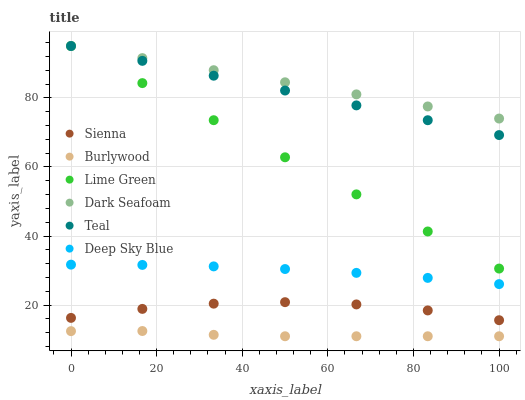Does Burlywood have the minimum area under the curve?
Answer yes or no. Yes. Does Dark Seafoam have the maximum area under the curve?
Answer yes or no. Yes. Does Sienna have the minimum area under the curve?
Answer yes or no. No. Does Sienna have the maximum area under the curve?
Answer yes or no. No. Is Lime Green the smoothest?
Answer yes or no. Yes. Is Sienna the roughest?
Answer yes or no. Yes. Is Burlywood the smoothest?
Answer yes or no. No. Is Burlywood the roughest?
Answer yes or no. No. Does Burlywood have the lowest value?
Answer yes or no. Yes. Does Sienna have the lowest value?
Answer yes or no. No. Does Lime Green have the highest value?
Answer yes or no. Yes. Does Sienna have the highest value?
Answer yes or no. No. Is Burlywood less than Deep Sky Blue?
Answer yes or no. Yes. Is Lime Green greater than Sienna?
Answer yes or no. Yes. Does Dark Seafoam intersect Lime Green?
Answer yes or no. Yes. Is Dark Seafoam less than Lime Green?
Answer yes or no. No. Is Dark Seafoam greater than Lime Green?
Answer yes or no. No. Does Burlywood intersect Deep Sky Blue?
Answer yes or no. No. 